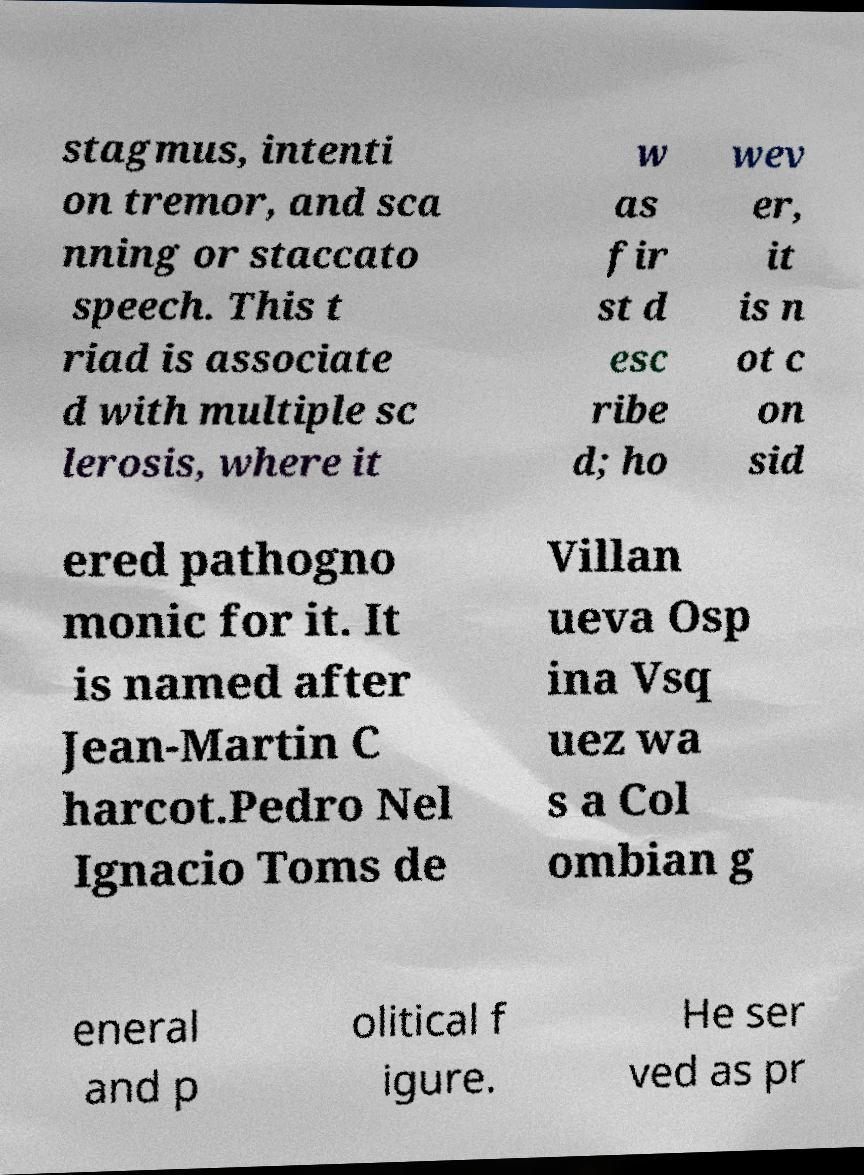What messages or text are displayed in this image? I need them in a readable, typed format. stagmus, intenti on tremor, and sca nning or staccato speech. This t riad is associate d with multiple sc lerosis, where it w as fir st d esc ribe d; ho wev er, it is n ot c on sid ered pathogno monic for it. It is named after Jean-Martin C harcot.Pedro Nel Ignacio Toms de Villan ueva Osp ina Vsq uez wa s a Col ombian g eneral and p olitical f igure. He ser ved as pr 